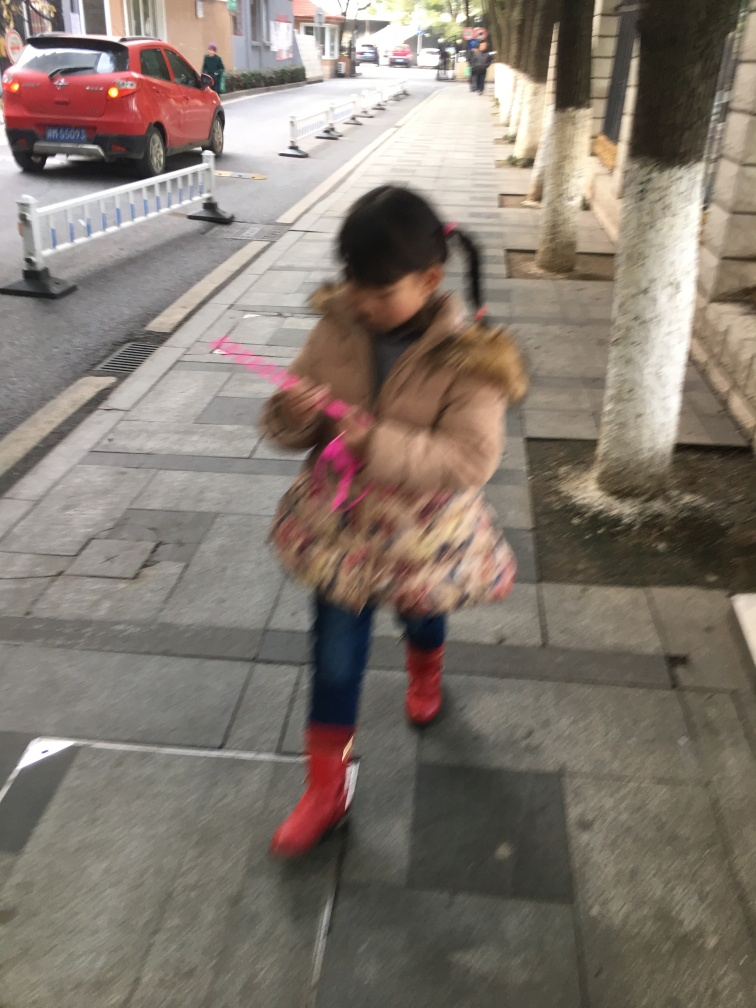What could be the reason for the blurriness of the image? The blurriness in the image is likely due to motion blur, which occurs when the subject moves during the camera's exposure. This suggests the photo was taken with a slower shutter speed, which wasn't fast enough to freeze the girl’s movement. Additionally, it could also be an intentional artistic choice to capture the dynamic nature of a child at play. How does the image make you feel, and why? While I don't have feelings, the image might evoke a sense of liveliness and childhood joy to a viewer. The blurriness captures the spontaneity of a child's movement, and the bright colors of the girl’s clothing against the more muted urban backdrop could give a feeling of vibrancy and playfulness. 